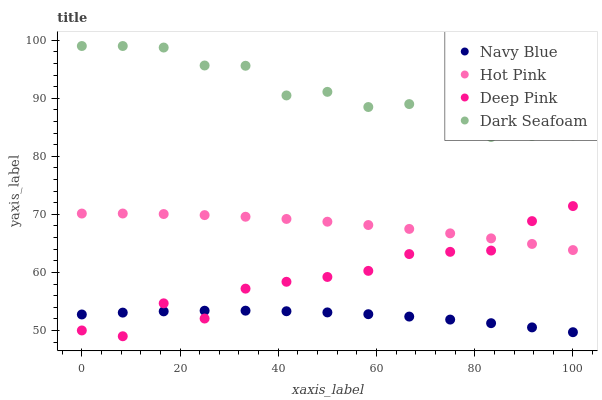Does Navy Blue have the minimum area under the curve?
Answer yes or no. Yes. Does Dark Seafoam have the maximum area under the curve?
Answer yes or no. Yes. Does Hot Pink have the minimum area under the curve?
Answer yes or no. No. Does Hot Pink have the maximum area under the curve?
Answer yes or no. No. Is Hot Pink the smoothest?
Answer yes or no. Yes. Is Deep Pink the roughest?
Answer yes or no. Yes. Is Dark Seafoam the smoothest?
Answer yes or no. No. Is Dark Seafoam the roughest?
Answer yes or no. No. Does Deep Pink have the lowest value?
Answer yes or no. Yes. Does Hot Pink have the lowest value?
Answer yes or no. No. Does Dark Seafoam have the highest value?
Answer yes or no. Yes. Does Hot Pink have the highest value?
Answer yes or no. No. Is Hot Pink less than Dark Seafoam?
Answer yes or no. Yes. Is Dark Seafoam greater than Deep Pink?
Answer yes or no. Yes. Does Hot Pink intersect Deep Pink?
Answer yes or no. Yes. Is Hot Pink less than Deep Pink?
Answer yes or no. No. Is Hot Pink greater than Deep Pink?
Answer yes or no. No. Does Hot Pink intersect Dark Seafoam?
Answer yes or no. No. 